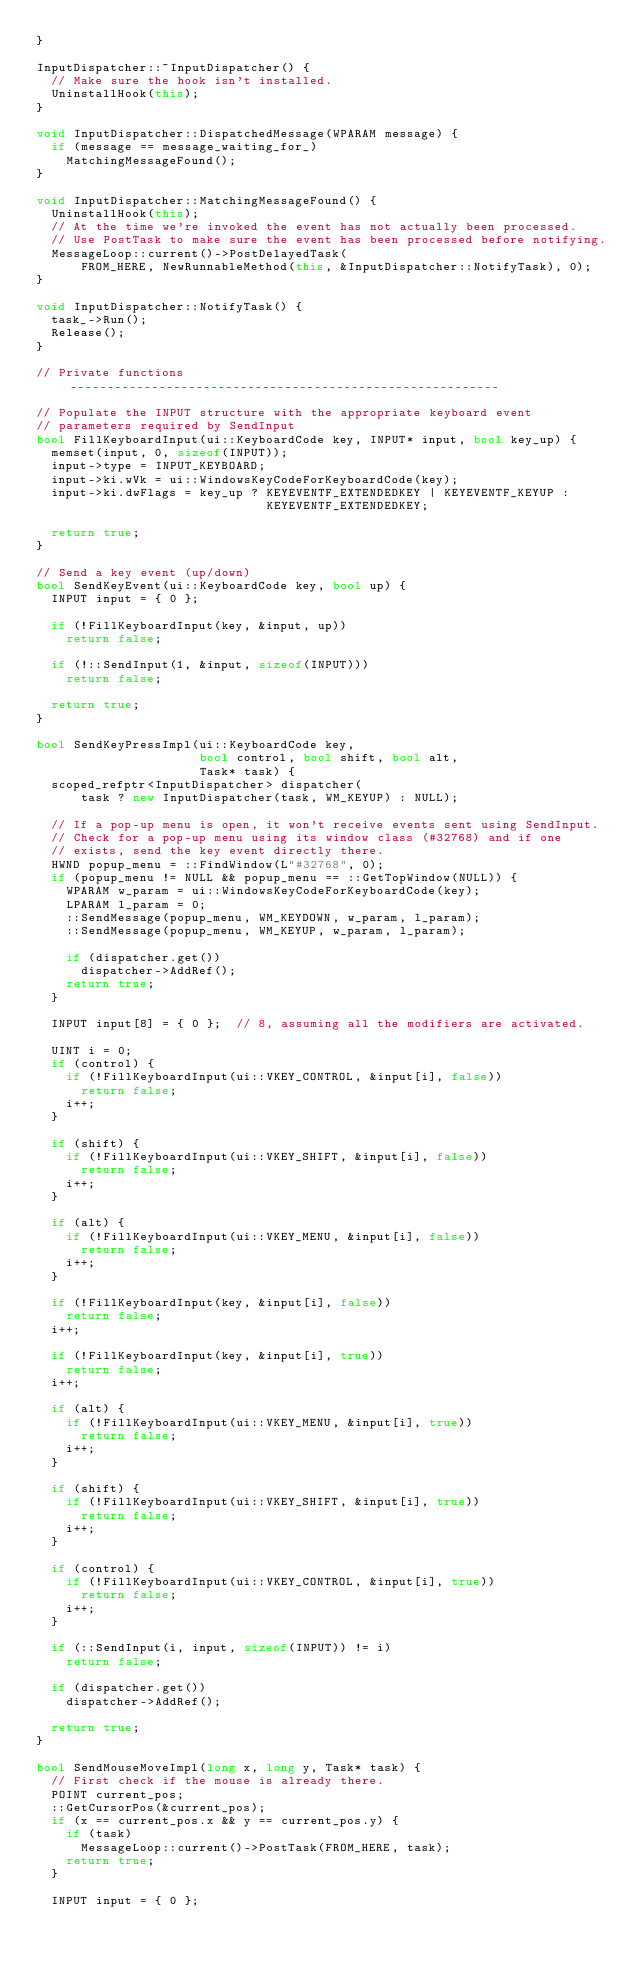Convert code to text. <code><loc_0><loc_0><loc_500><loc_500><_C++_>}

InputDispatcher::~InputDispatcher() {
  // Make sure the hook isn't installed.
  UninstallHook(this);
}

void InputDispatcher::DispatchedMessage(WPARAM message) {
  if (message == message_waiting_for_)
    MatchingMessageFound();
}

void InputDispatcher::MatchingMessageFound() {
  UninstallHook(this);
  // At the time we're invoked the event has not actually been processed.
  // Use PostTask to make sure the event has been processed before notifying.
  MessageLoop::current()->PostDelayedTask(
      FROM_HERE, NewRunnableMethod(this, &InputDispatcher::NotifyTask), 0);
}

void InputDispatcher::NotifyTask() {
  task_->Run();
  Release();
}

// Private functions ----------------------------------------------------------

// Populate the INPUT structure with the appropriate keyboard event
// parameters required by SendInput
bool FillKeyboardInput(ui::KeyboardCode key, INPUT* input, bool key_up) {
  memset(input, 0, sizeof(INPUT));
  input->type = INPUT_KEYBOARD;
  input->ki.wVk = ui::WindowsKeyCodeForKeyboardCode(key);
  input->ki.dwFlags = key_up ? KEYEVENTF_EXTENDEDKEY | KEYEVENTF_KEYUP :
                               KEYEVENTF_EXTENDEDKEY;

  return true;
}

// Send a key event (up/down)
bool SendKeyEvent(ui::KeyboardCode key, bool up) {
  INPUT input = { 0 };

  if (!FillKeyboardInput(key, &input, up))
    return false;

  if (!::SendInput(1, &input, sizeof(INPUT)))
    return false;

  return true;
}

bool SendKeyPressImpl(ui::KeyboardCode key,
                      bool control, bool shift, bool alt,
                      Task* task) {
  scoped_refptr<InputDispatcher> dispatcher(
      task ? new InputDispatcher(task, WM_KEYUP) : NULL);

  // If a pop-up menu is open, it won't receive events sent using SendInput.
  // Check for a pop-up menu using its window class (#32768) and if one
  // exists, send the key event directly there.
  HWND popup_menu = ::FindWindow(L"#32768", 0);
  if (popup_menu != NULL && popup_menu == ::GetTopWindow(NULL)) {
    WPARAM w_param = ui::WindowsKeyCodeForKeyboardCode(key);
    LPARAM l_param = 0;
    ::SendMessage(popup_menu, WM_KEYDOWN, w_param, l_param);
    ::SendMessage(popup_menu, WM_KEYUP, w_param, l_param);

    if (dispatcher.get())
      dispatcher->AddRef();
    return true;
  }

  INPUT input[8] = { 0 };  // 8, assuming all the modifiers are activated.

  UINT i = 0;
  if (control) {
    if (!FillKeyboardInput(ui::VKEY_CONTROL, &input[i], false))
      return false;
    i++;
  }

  if (shift) {
    if (!FillKeyboardInput(ui::VKEY_SHIFT, &input[i], false))
      return false;
    i++;
  }

  if (alt) {
    if (!FillKeyboardInput(ui::VKEY_MENU, &input[i], false))
      return false;
    i++;
  }

  if (!FillKeyboardInput(key, &input[i], false))
    return false;
  i++;

  if (!FillKeyboardInput(key, &input[i], true))
    return false;
  i++;

  if (alt) {
    if (!FillKeyboardInput(ui::VKEY_MENU, &input[i], true))
      return false;
    i++;
  }

  if (shift) {
    if (!FillKeyboardInput(ui::VKEY_SHIFT, &input[i], true))
      return false;
    i++;
  }

  if (control) {
    if (!FillKeyboardInput(ui::VKEY_CONTROL, &input[i], true))
      return false;
    i++;
  }

  if (::SendInput(i, input, sizeof(INPUT)) != i)
    return false;

  if (dispatcher.get())
    dispatcher->AddRef();

  return true;
}

bool SendMouseMoveImpl(long x, long y, Task* task) {
  // First check if the mouse is already there.
  POINT current_pos;
  ::GetCursorPos(&current_pos);
  if (x == current_pos.x && y == current_pos.y) {
    if (task)
      MessageLoop::current()->PostTask(FROM_HERE, task);
    return true;
  }

  INPUT input = { 0 };
</code> 